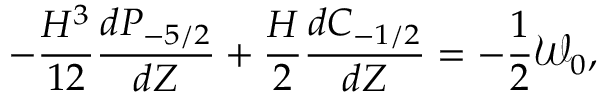Convert formula to latex. <formula><loc_0><loc_0><loc_500><loc_500>- \frac { H ^ { 3 } } { 1 2 } \frac { d P _ { - 5 / 2 } } { d Z } + \frac { H } { 2 } \frac { d C _ { - 1 / 2 } } { d Z } = - \frac { 1 } { 2 } \mathcal { W } _ { 0 } ,</formula> 